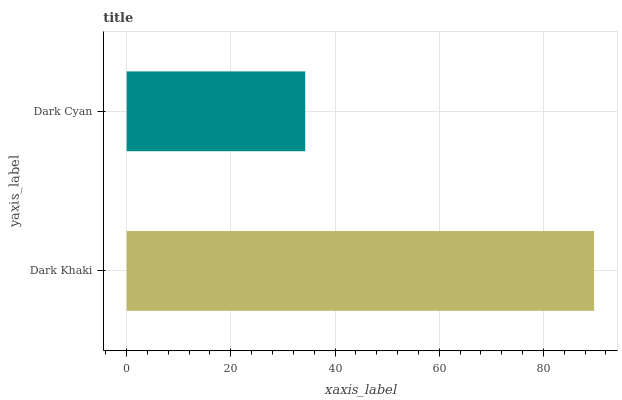Is Dark Cyan the minimum?
Answer yes or no. Yes. Is Dark Khaki the maximum?
Answer yes or no. Yes. Is Dark Cyan the maximum?
Answer yes or no. No. Is Dark Khaki greater than Dark Cyan?
Answer yes or no. Yes. Is Dark Cyan less than Dark Khaki?
Answer yes or no. Yes. Is Dark Cyan greater than Dark Khaki?
Answer yes or no. No. Is Dark Khaki less than Dark Cyan?
Answer yes or no. No. Is Dark Khaki the high median?
Answer yes or no. Yes. Is Dark Cyan the low median?
Answer yes or no. Yes. Is Dark Cyan the high median?
Answer yes or no. No. Is Dark Khaki the low median?
Answer yes or no. No. 